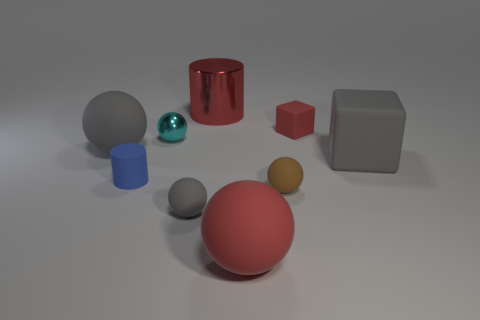Are there any other things that are the same size as the cyan metallic sphere?
Ensure brevity in your answer.  Yes. Is there any other thing that has the same material as the large gray ball?
Your answer should be compact. Yes. Do the cube to the right of the tiny rubber cube and the big metal cylinder have the same color?
Your answer should be compact. No. There is a gray ball that is in front of the small rubber ball on the right side of the metal cylinder; is there a big red rubber ball behind it?
Provide a succinct answer. No. What shape is the rubber object that is both behind the big gray cube and left of the tiny rubber cube?
Give a very brief answer. Sphere. Are there any big objects of the same color as the big matte cube?
Your answer should be very brief. Yes. There is a rubber sphere behind the tiny matte sphere right of the metallic cylinder; what is its color?
Offer a terse response. Gray. What is the size of the cylinder behind the rubber cube behind the large thing to the right of the tiny red cube?
Give a very brief answer. Large. Is the cyan thing made of the same material as the tiny thing that is right of the tiny brown matte sphere?
Give a very brief answer. No. What size is the red sphere that is the same material as the brown sphere?
Your answer should be very brief. Large. 